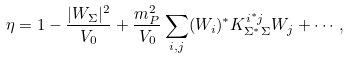Convert formula to latex. <formula><loc_0><loc_0><loc_500><loc_500>\eta = 1 - \frac { | W _ { \Sigma } | ^ { 2 } } { V _ { 0 } } + \frac { m _ { P } ^ { 2 } } { V _ { 0 } } \sum _ { i , j } ( W _ { i } ) ^ { * } K ^ { i ^ { * } j } _ { \Sigma ^ { * } \Sigma } W _ { j } + \cdots ,</formula> 